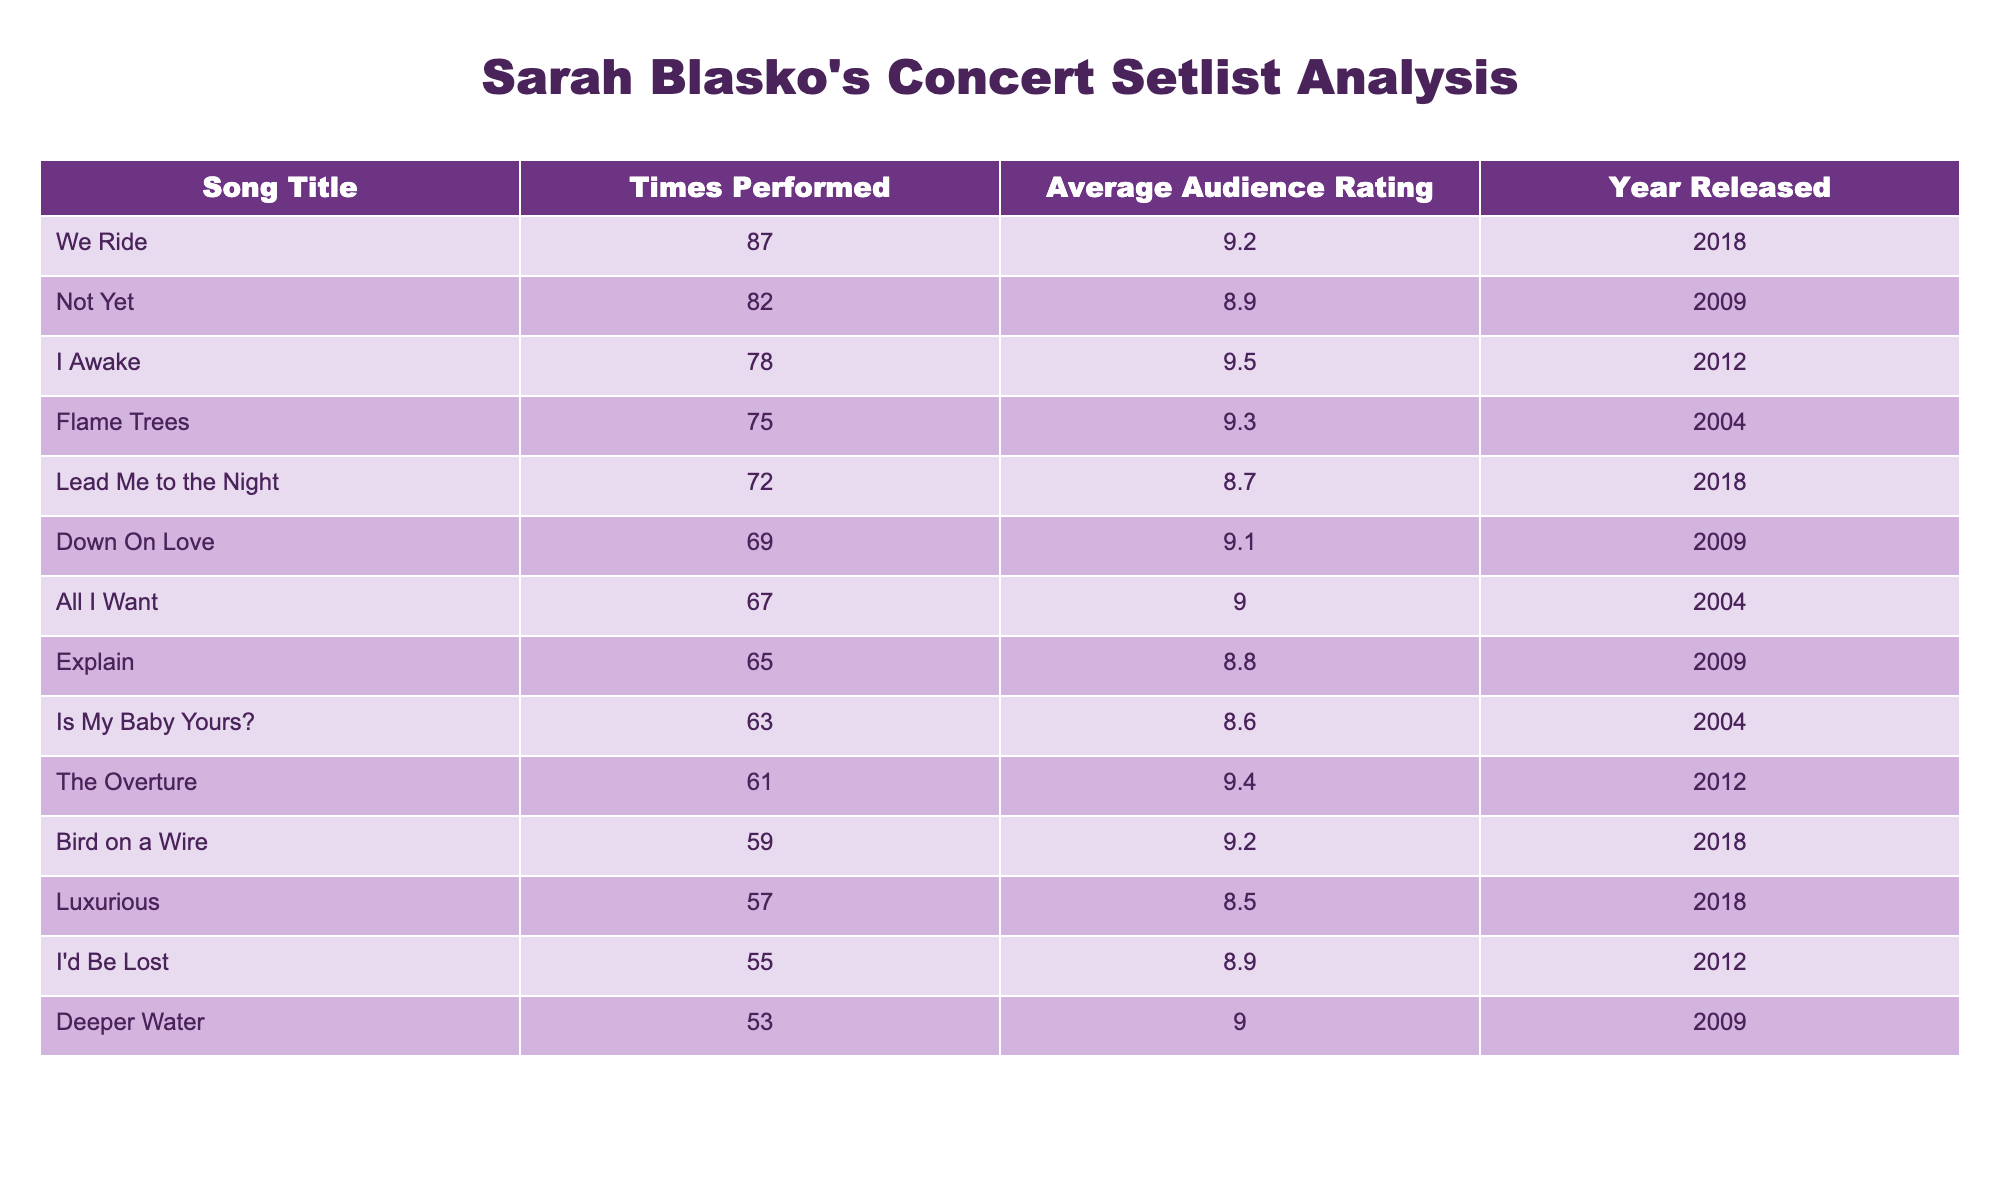What is the song with the highest average audience rating? From the table, I can see the column for "Average Audience Rating" and find that "I Awake" has the highest rating of 9.5.
Answer: I Awake How many times was "Bird on a Wire" performed? Looking at the "Times Performed" column, "Bird on a Wire" appears 59 times.
Answer: 59 Which song has the lowest average audience rating? By checking the "Average Audience Rating" column, I find that "Luxurious" has the lowest rating of 8.5.
Answer: Luxurious What is the total number of performances for the songs released in 2009? I will find the songs from the year 2009: "Not Yet," "Down On Love," "Explain," and "Deeper Water." Adding their performances: 82 + 69 + 65 + 53 = 269.
Answer: 269 True or false: "We Ride" was performed more times than "Flame Trees." Comparing the "Times Performed," "We Ride" was performed 87 times, while "Flame Trees" was performed 75 times, which means the statement is true.
Answer: True What is the difference in average ratings between the most performed song and the second most performed song? The most performed song is "We Ride" with an average rating of 9.2, and the second most performed song is "Not Yet" with an average rating of 8.9. The difference is 9.2 - 8.9 = 0.3.
Answer: 0.3 Which song has a higher average audience rating: "Down On Love" or "All I Want"? "Down On Love" has an average rating of 9.1, while "All I Want" has a rating of 9.0. Since 9.1 is greater than 9.0, "Down On Love" has a higher rating.
Answer: Down On Love What is the average audience rating for all songs released in 2012? The songs from 2012 are "I Awake" and "The Overture," with ratings of 9.5 and 9.4. The average rating is (9.5 + 9.4) / 2 = 9.45.
Answer: 9.45 How many songs have an average audience rating of 9.0 or higher? Referring to the "Average Audience Rating" column, the songs that meet or exceed 9.0 are "We Ride," "I Awake," "Flame Trees," "The Overture," "Bird on a Wire," "Down On Love," "All I Want," and "Deeper Water." That's a total of 8 songs.
Answer: 8 What was the overall trend in average audience ratings with respect to the years? Evaluating the average ratings by year, I see that 2018 has songs rated 9.2 and lower, 2012 has high ratings of 9.5 and 9.4, and 2009 has a range of 8.6 to 9.1, suggesting ratings fluctuated but peaked in 2012.
Answer: Ratings peaked in 2012 